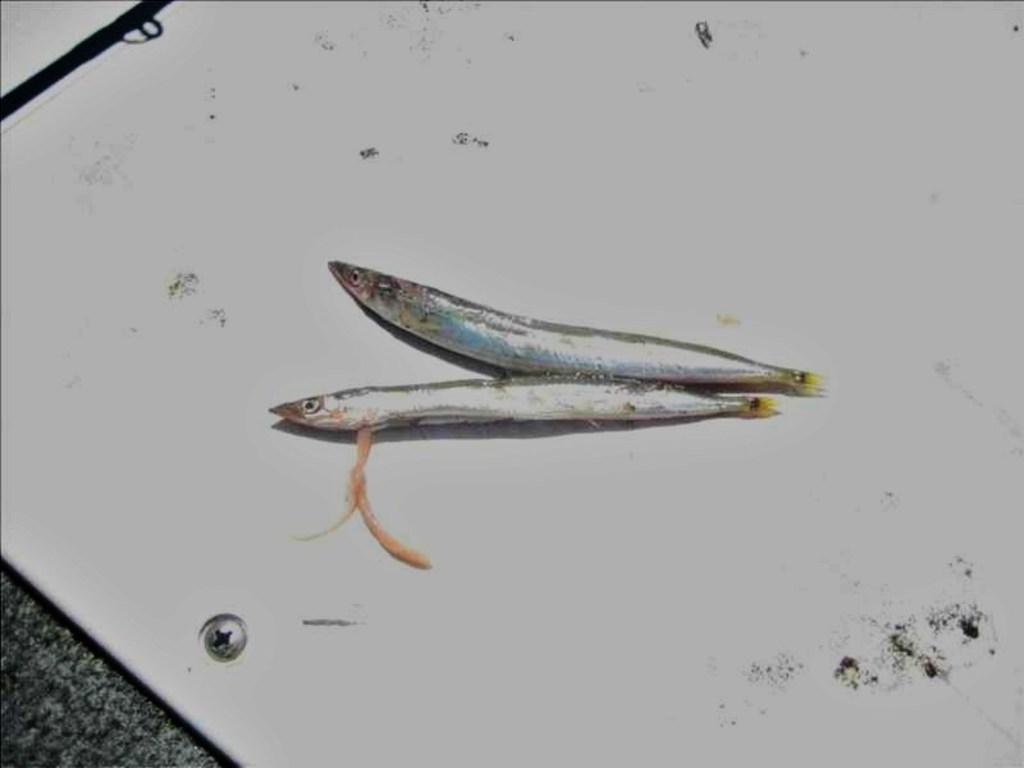Describe this image in one or two sentences. In this image, we can see fishes on object. 